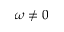<formula> <loc_0><loc_0><loc_500><loc_500>\omega \neq 0</formula> 